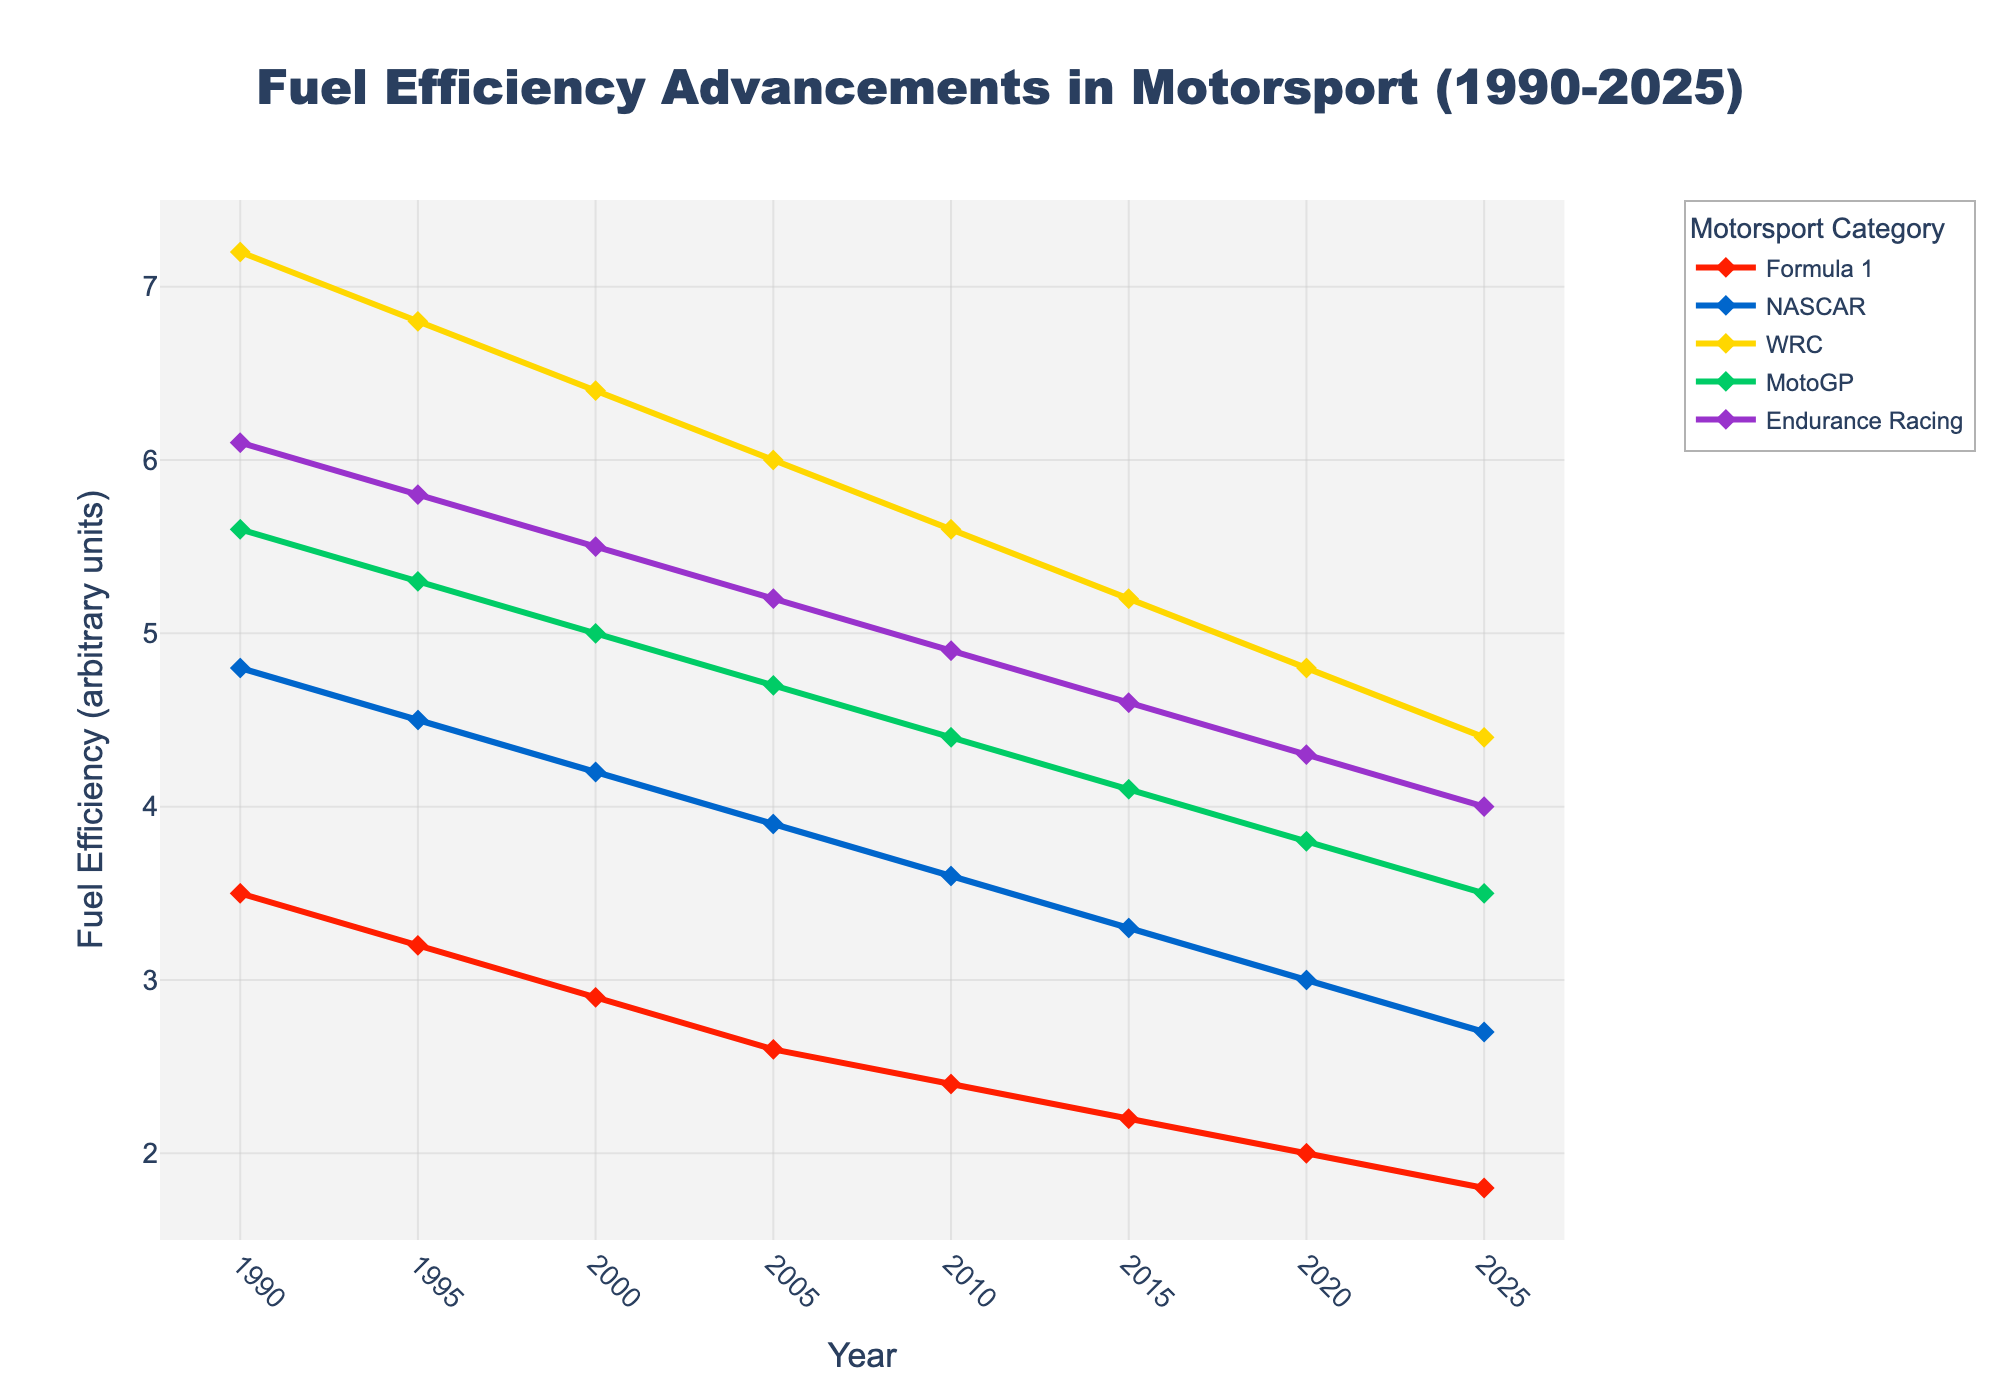What's the improvement in fuel efficiency for Formula 1 from 1990 to 2025? To find the fuel efficiency improvement for Formula 1 from 1990 to 2025, subtract the 2025 value from the 1990 value: 3.5 (in 1990) - 1.8 (in 2025) = 1.7
Answer: 1.7 In what year did NASCAR reach a fuel efficiency of 3.0? Examine the trend line for NASCAR. The efficiency reaches 3.0 in the year 2020.
Answer: 2020 Which motorsport category shows the highest fuel efficiency in 2025? Compare the fuel efficiency values for all categories in 2025. The lowest value indicates the highest efficiency. Formula 1 shows the highest efficiency at 1.8.
Answer: Formula 1 What is the average fuel efficiency of Endurance Racing from 1990 to 2025? Add all Endurance Racing efficiency values and divide by the number of data points: (6.1 + 5.8 + 5.5 + 5.2 + 4.9 + 4.6 + 4.3 + 4.0)/8 = 5.05
Answer: 5.05 By how much did MotoGP's fuel efficiency improve between 2000 and 2020? Subtract MotoGP's 2020 value from its 2000 value: 5.0 - 3.8 = 1.2
Answer: 1.2 Which category had the least improvement in fuel efficiency from 1990 to 2025? Calculate the difference between 1990 and 2025 for each category and find the smallest value: WRC (7.2-4.4=2.8), Endurance Racing (6.1-4.0=2.1), NASCAR (4.8-2.7=2.1), MotoGP (5.6-3.5=2.1), and Formula 1 (3.5-1.8=1.7). WRC has the least improvement with 2.8.
Answer: WRC Which motorsport category showed a consistent improvement over each time period? A category shows consistent improvement if its line continuously declines with no increase. Verify for each category. Formula 1 shows consistent improvement.
Answer: Formula 1 How many units did MotoGP's fuel efficiency improve from 1995 to 2005? Subtract MotoGP's 1995 value from its 2005 value: 5.3 - 4.7 = 0.6
Answer: 0.6 Which motorsport category had the largest drop in fuel efficiency from the year 2000 to 2005? Calculate the difference for each category from 2000 to 2005 and find the largest drop: Formula 1 (0.3), NASCAR (0.3), WRC (0.4), MotoGP (0.3), Endurance Racing (0.3). WRC had the largest drop at 0.4.
Answer: WRC Which color represents the WRC category on the plot? Identify the line color corresponding to the "WRC" label. WRC is represented by a yellow line.
Answer: Yellow 